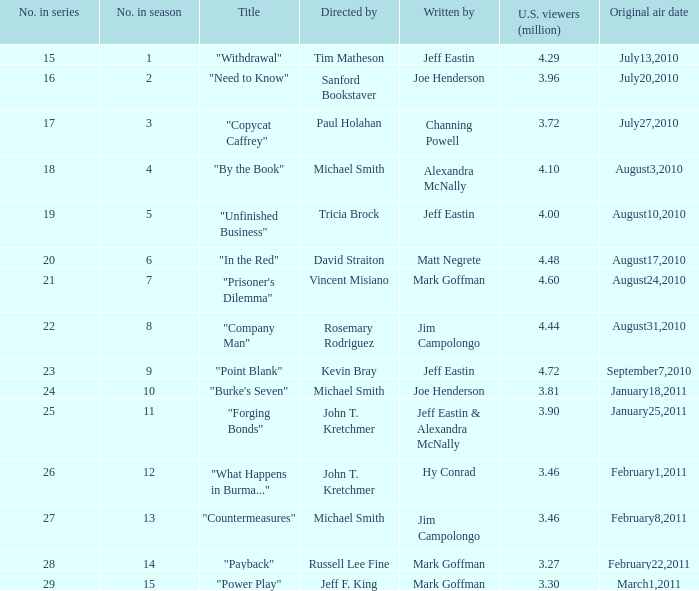Who directed the episode "Point Blank"? Kevin Bray. 